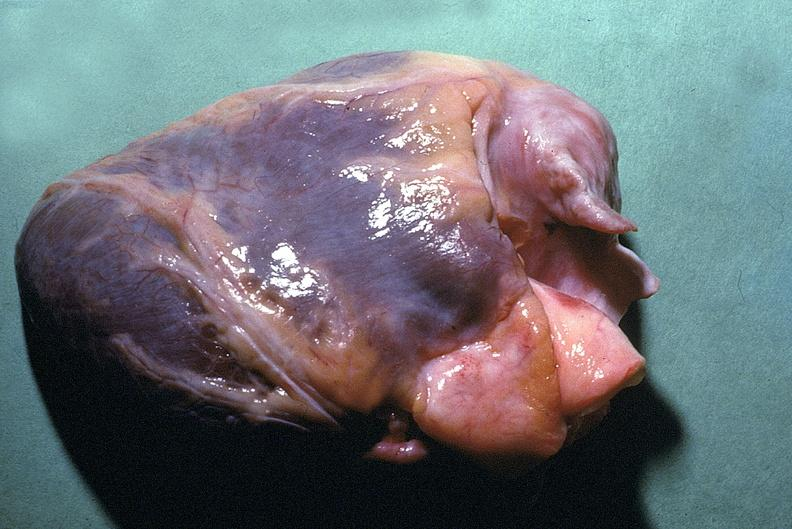where is this?
Answer the question using a single word or phrase. Heart 